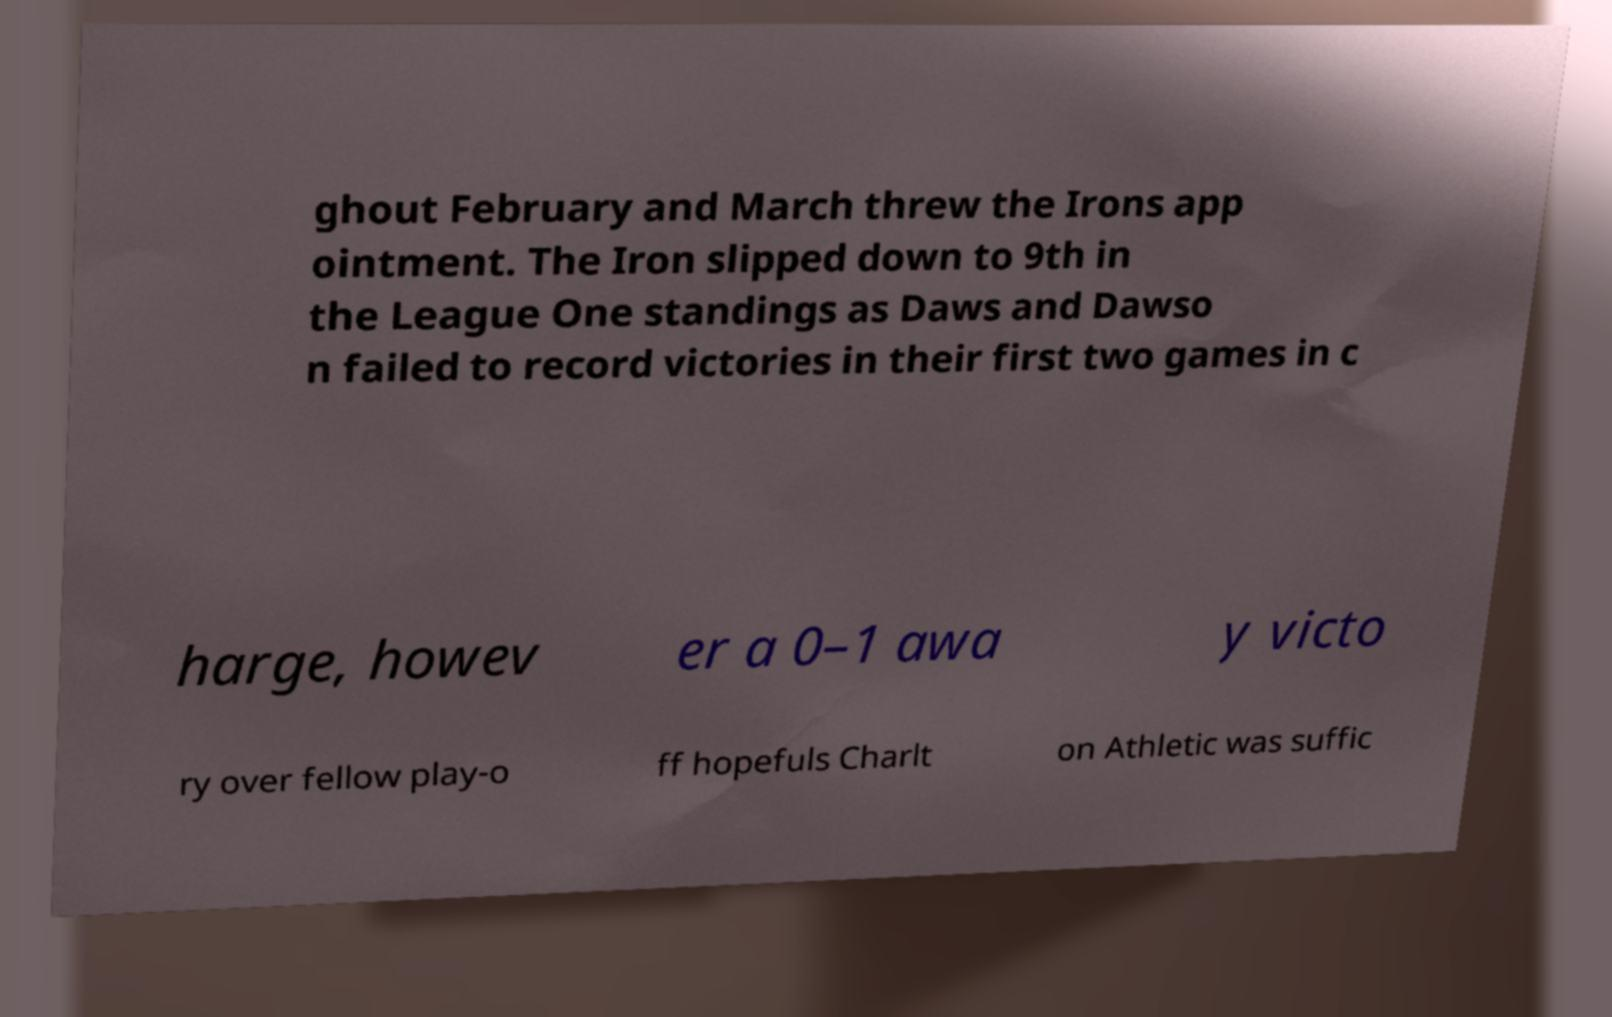Could you extract and type out the text from this image? ghout February and March threw the Irons app ointment. The Iron slipped down to 9th in the League One standings as Daws and Dawso n failed to record victories in their first two games in c harge, howev er a 0–1 awa y victo ry over fellow play-o ff hopefuls Charlt on Athletic was suffic 